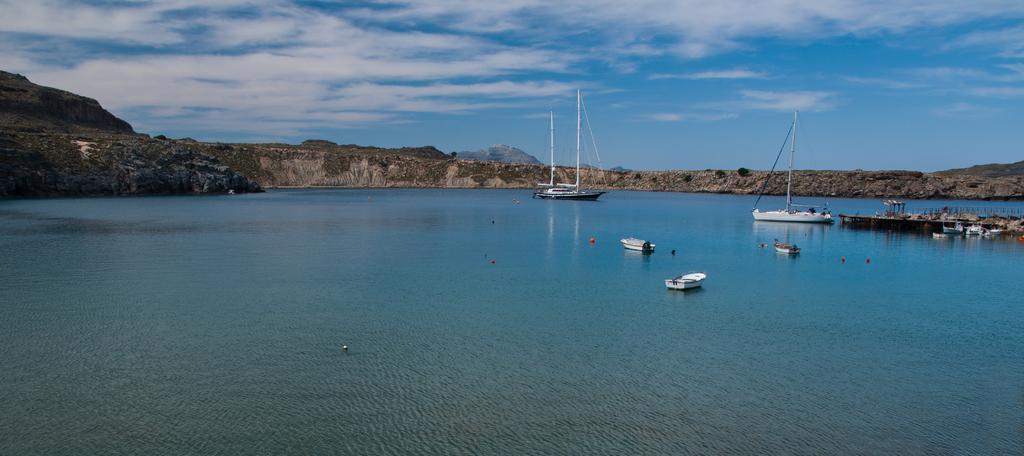Please provide a concise description of this image. We can see ships, boats and objects above the water. We can see bridge. In the background we can see grass, hill and sky with clouds. 